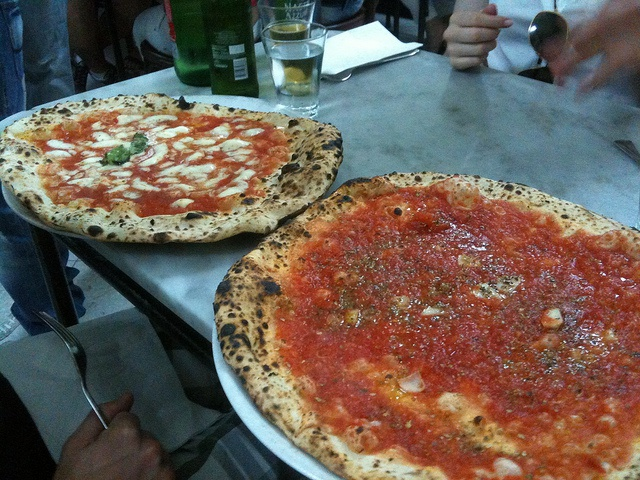Describe the objects in this image and their specific colors. I can see pizza in navy, brown, and maroon tones, dining table in navy, gray, black, and teal tones, pizza in navy, darkgray, tan, gray, and brown tones, people in navy, black, and purple tones, and people in navy, gray, and black tones in this image. 